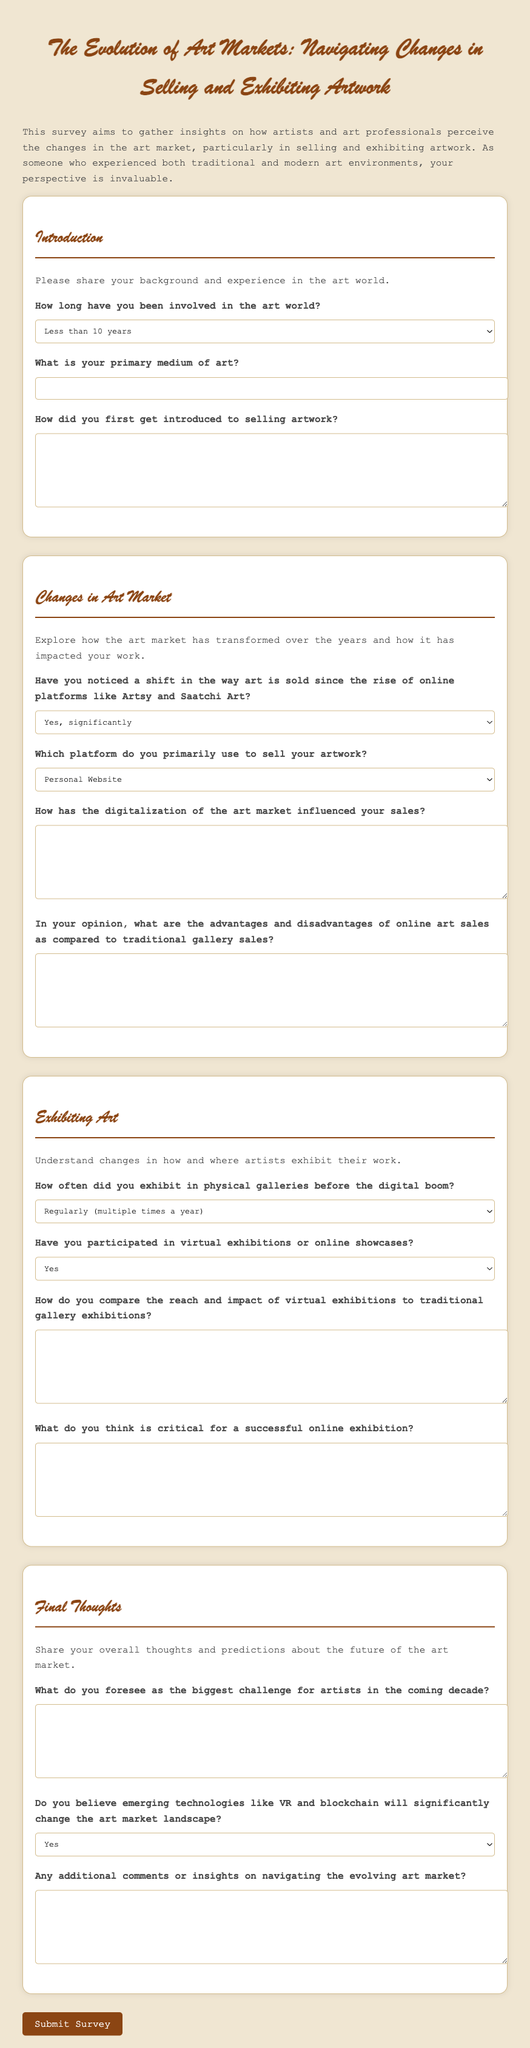What is the title of the survey? The title of the survey is prominently displayed at the top of the document.
Answer: The Evolution of Art Markets: Navigating Changes in Selling and Exhibiting Artwork How long can respondents indicate they have been involved in the art world? Respondents can choose from three time ranges concerning their involvement in the art world.
Answer: Less than 10 years, 10-20 years, More than 20 years What two platforms are mentioned in the question about a shift in the way art is sold? The question highlights two online platforms that have influenced the selling of art.
Answer: Artsy and Saatchi Art What is one critical aspect mentioned for a successful online exhibition? The survey specifically asks about a defining factor for success in the context of online exhibitions.
Answer: Open-ended response What is the final question about the future of artists in the coming decade? The last question asks for respondents' views on a potential challenge that artists may face in the future.
Answer: Open-ended response 